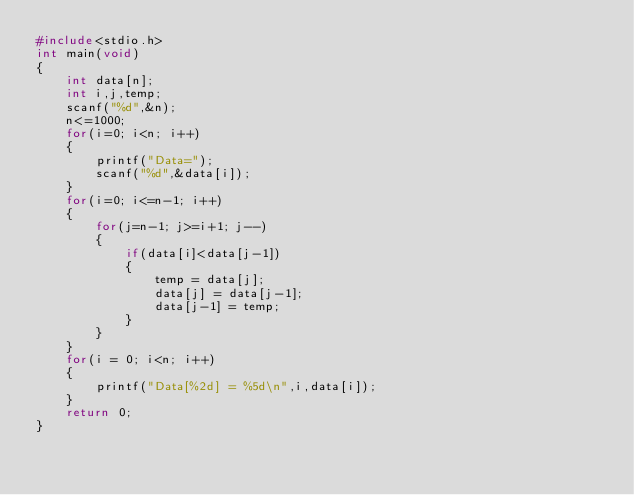<code> <loc_0><loc_0><loc_500><loc_500><_C_>#include<stdio.h>
int main(void)
{
	int data[n];
	int i,j,temp;
	scanf("%d",&n);
	n<=1000;
	for(i=0; i<n; i++)
	{
		printf("Data=");
		scanf("%d",&data[i]);
	}
	for(i=0; i<=n-1; i++)
	{
		for(j=n-1; j>=i+1; j--)
		{
			if(data[i]<data[j-1])
			{
				temp = data[j];
				data[j] = data[j-1];
				data[j-1] = temp;
			}
		}
	}
	for(i = 0; i<n; i++)
	{
		printf("Data[%2d] = %5d\n",i,data[i]);
	}
	return 0;
}</code> 